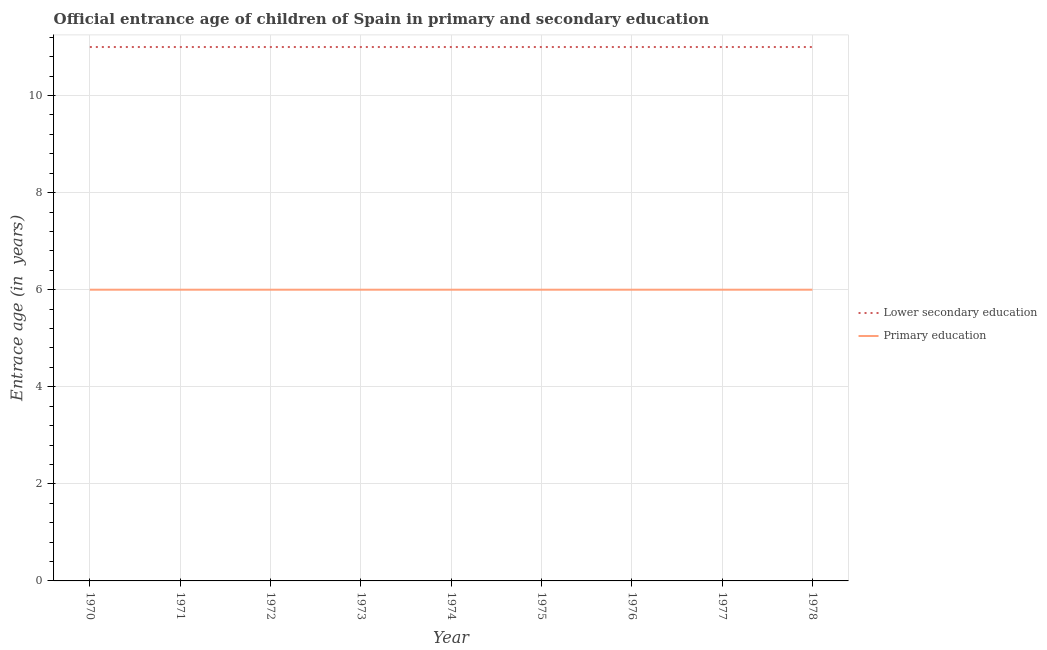How many different coloured lines are there?
Offer a terse response. 2. Does the line corresponding to entrance age of chiildren in primary education intersect with the line corresponding to entrance age of children in lower secondary education?
Offer a very short reply. No. What is the entrance age of chiildren in primary education in 1977?
Keep it short and to the point. 6. Across all years, what is the maximum entrance age of children in lower secondary education?
Your response must be concise. 11. Across all years, what is the minimum entrance age of children in lower secondary education?
Make the answer very short. 11. What is the total entrance age of children in lower secondary education in the graph?
Keep it short and to the point. 99. What is the difference between the entrance age of children in lower secondary education in 1978 and the entrance age of chiildren in primary education in 1973?
Keep it short and to the point. 5. What is the average entrance age of children in lower secondary education per year?
Give a very brief answer. 11. In the year 1978, what is the difference between the entrance age of chiildren in primary education and entrance age of children in lower secondary education?
Your response must be concise. -5. Is the entrance age of chiildren in primary education in 1977 less than that in 1978?
Ensure brevity in your answer.  No. In how many years, is the entrance age of chiildren in primary education greater than the average entrance age of chiildren in primary education taken over all years?
Offer a very short reply. 0. Does the entrance age of children in lower secondary education monotonically increase over the years?
Keep it short and to the point. No. What is the difference between two consecutive major ticks on the Y-axis?
Provide a short and direct response. 2. Does the graph contain any zero values?
Offer a terse response. No. Where does the legend appear in the graph?
Keep it short and to the point. Center right. What is the title of the graph?
Ensure brevity in your answer.  Official entrance age of children of Spain in primary and secondary education. Does "Malaria" appear as one of the legend labels in the graph?
Give a very brief answer. No. What is the label or title of the Y-axis?
Your answer should be very brief. Entrace age (in  years). What is the Entrace age (in  years) in Lower secondary education in 1970?
Offer a very short reply. 11. What is the Entrace age (in  years) of Lower secondary education in 1972?
Offer a very short reply. 11. What is the Entrace age (in  years) of Lower secondary education in 1973?
Give a very brief answer. 11. What is the Entrace age (in  years) in Primary education in 1973?
Offer a very short reply. 6. What is the Entrace age (in  years) in Lower secondary education in 1974?
Keep it short and to the point. 11. What is the Entrace age (in  years) of Lower secondary education in 1975?
Give a very brief answer. 11. What is the Entrace age (in  years) in Lower secondary education in 1977?
Offer a terse response. 11. Across all years, what is the maximum Entrace age (in  years) of Primary education?
Offer a terse response. 6. Across all years, what is the minimum Entrace age (in  years) in Lower secondary education?
Make the answer very short. 11. Across all years, what is the minimum Entrace age (in  years) of Primary education?
Keep it short and to the point. 6. What is the total Entrace age (in  years) in Lower secondary education in the graph?
Offer a terse response. 99. What is the difference between the Entrace age (in  years) in Lower secondary education in 1970 and that in 1971?
Give a very brief answer. 0. What is the difference between the Entrace age (in  years) in Lower secondary education in 1970 and that in 1972?
Make the answer very short. 0. What is the difference between the Entrace age (in  years) of Lower secondary education in 1970 and that in 1973?
Offer a very short reply. 0. What is the difference between the Entrace age (in  years) of Primary education in 1970 and that in 1973?
Offer a very short reply. 0. What is the difference between the Entrace age (in  years) of Lower secondary education in 1970 and that in 1974?
Keep it short and to the point. 0. What is the difference between the Entrace age (in  years) of Lower secondary education in 1970 and that in 1975?
Your answer should be very brief. 0. What is the difference between the Entrace age (in  years) in Primary education in 1970 and that in 1975?
Your response must be concise. 0. What is the difference between the Entrace age (in  years) of Lower secondary education in 1970 and that in 1976?
Make the answer very short. 0. What is the difference between the Entrace age (in  years) in Primary education in 1970 and that in 1976?
Your response must be concise. 0. What is the difference between the Entrace age (in  years) in Lower secondary education in 1970 and that in 1978?
Offer a terse response. 0. What is the difference between the Entrace age (in  years) in Lower secondary education in 1971 and that in 1973?
Offer a terse response. 0. What is the difference between the Entrace age (in  years) in Primary education in 1971 and that in 1974?
Make the answer very short. 0. What is the difference between the Entrace age (in  years) of Lower secondary education in 1971 and that in 1978?
Ensure brevity in your answer.  0. What is the difference between the Entrace age (in  years) of Primary education in 1971 and that in 1978?
Give a very brief answer. 0. What is the difference between the Entrace age (in  years) in Lower secondary education in 1972 and that in 1975?
Ensure brevity in your answer.  0. What is the difference between the Entrace age (in  years) of Primary education in 1972 and that in 1976?
Provide a short and direct response. 0. What is the difference between the Entrace age (in  years) of Lower secondary education in 1972 and that in 1977?
Provide a short and direct response. 0. What is the difference between the Entrace age (in  years) in Primary education in 1972 and that in 1977?
Make the answer very short. 0. What is the difference between the Entrace age (in  years) in Lower secondary education in 1972 and that in 1978?
Your answer should be very brief. 0. What is the difference between the Entrace age (in  years) of Primary education in 1972 and that in 1978?
Offer a terse response. 0. What is the difference between the Entrace age (in  years) of Lower secondary education in 1973 and that in 1974?
Your answer should be compact. 0. What is the difference between the Entrace age (in  years) in Primary education in 1973 and that in 1974?
Provide a succinct answer. 0. What is the difference between the Entrace age (in  years) in Primary education in 1973 and that in 1975?
Your answer should be very brief. 0. What is the difference between the Entrace age (in  years) in Lower secondary education in 1973 and that in 1978?
Your answer should be very brief. 0. What is the difference between the Entrace age (in  years) of Primary education in 1973 and that in 1978?
Ensure brevity in your answer.  0. What is the difference between the Entrace age (in  years) in Primary education in 1974 and that in 1976?
Provide a short and direct response. 0. What is the difference between the Entrace age (in  years) of Primary education in 1974 and that in 1977?
Provide a succinct answer. 0. What is the difference between the Entrace age (in  years) in Lower secondary education in 1974 and that in 1978?
Make the answer very short. 0. What is the difference between the Entrace age (in  years) of Primary education in 1974 and that in 1978?
Provide a short and direct response. 0. What is the difference between the Entrace age (in  years) in Lower secondary education in 1975 and that in 1976?
Ensure brevity in your answer.  0. What is the difference between the Entrace age (in  years) in Lower secondary education in 1975 and that in 1978?
Make the answer very short. 0. What is the difference between the Entrace age (in  years) in Primary education in 1976 and that in 1977?
Your answer should be compact. 0. What is the difference between the Entrace age (in  years) in Lower secondary education in 1976 and that in 1978?
Offer a terse response. 0. What is the difference between the Entrace age (in  years) in Primary education in 1977 and that in 1978?
Provide a short and direct response. 0. What is the difference between the Entrace age (in  years) of Lower secondary education in 1970 and the Entrace age (in  years) of Primary education in 1971?
Give a very brief answer. 5. What is the difference between the Entrace age (in  years) in Lower secondary education in 1970 and the Entrace age (in  years) in Primary education in 1973?
Give a very brief answer. 5. What is the difference between the Entrace age (in  years) of Lower secondary education in 1970 and the Entrace age (in  years) of Primary education in 1974?
Provide a succinct answer. 5. What is the difference between the Entrace age (in  years) of Lower secondary education in 1970 and the Entrace age (in  years) of Primary education in 1976?
Your answer should be compact. 5. What is the difference between the Entrace age (in  years) of Lower secondary education in 1970 and the Entrace age (in  years) of Primary education in 1977?
Give a very brief answer. 5. What is the difference between the Entrace age (in  years) in Lower secondary education in 1970 and the Entrace age (in  years) in Primary education in 1978?
Offer a terse response. 5. What is the difference between the Entrace age (in  years) in Lower secondary education in 1971 and the Entrace age (in  years) in Primary education in 1972?
Ensure brevity in your answer.  5. What is the difference between the Entrace age (in  years) in Lower secondary education in 1971 and the Entrace age (in  years) in Primary education in 1974?
Provide a succinct answer. 5. What is the difference between the Entrace age (in  years) of Lower secondary education in 1971 and the Entrace age (in  years) of Primary education in 1976?
Your answer should be very brief. 5. What is the difference between the Entrace age (in  years) in Lower secondary education in 1971 and the Entrace age (in  years) in Primary education in 1978?
Your answer should be very brief. 5. What is the difference between the Entrace age (in  years) in Lower secondary education in 1972 and the Entrace age (in  years) in Primary education in 1974?
Make the answer very short. 5. What is the difference between the Entrace age (in  years) of Lower secondary education in 1972 and the Entrace age (in  years) of Primary education in 1975?
Provide a short and direct response. 5. What is the difference between the Entrace age (in  years) of Lower secondary education in 1972 and the Entrace age (in  years) of Primary education in 1976?
Keep it short and to the point. 5. What is the difference between the Entrace age (in  years) in Lower secondary education in 1972 and the Entrace age (in  years) in Primary education in 1977?
Offer a very short reply. 5. What is the difference between the Entrace age (in  years) of Lower secondary education in 1972 and the Entrace age (in  years) of Primary education in 1978?
Keep it short and to the point. 5. What is the difference between the Entrace age (in  years) in Lower secondary education in 1973 and the Entrace age (in  years) in Primary education in 1975?
Keep it short and to the point. 5. What is the difference between the Entrace age (in  years) in Lower secondary education in 1973 and the Entrace age (in  years) in Primary education in 1976?
Make the answer very short. 5. What is the difference between the Entrace age (in  years) of Lower secondary education in 1973 and the Entrace age (in  years) of Primary education in 1977?
Ensure brevity in your answer.  5. What is the difference between the Entrace age (in  years) in Lower secondary education in 1973 and the Entrace age (in  years) in Primary education in 1978?
Give a very brief answer. 5. What is the difference between the Entrace age (in  years) of Lower secondary education in 1976 and the Entrace age (in  years) of Primary education in 1977?
Provide a succinct answer. 5. What is the difference between the Entrace age (in  years) of Lower secondary education in 1976 and the Entrace age (in  years) of Primary education in 1978?
Keep it short and to the point. 5. What is the difference between the Entrace age (in  years) of Lower secondary education in 1977 and the Entrace age (in  years) of Primary education in 1978?
Your answer should be very brief. 5. What is the average Entrace age (in  years) of Lower secondary education per year?
Keep it short and to the point. 11. In the year 1970, what is the difference between the Entrace age (in  years) in Lower secondary education and Entrace age (in  years) in Primary education?
Your answer should be very brief. 5. In the year 1972, what is the difference between the Entrace age (in  years) in Lower secondary education and Entrace age (in  years) in Primary education?
Your answer should be very brief. 5. In the year 1975, what is the difference between the Entrace age (in  years) of Lower secondary education and Entrace age (in  years) of Primary education?
Your response must be concise. 5. In the year 1976, what is the difference between the Entrace age (in  years) of Lower secondary education and Entrace age (in  years) of Primary education?
Your response must be concise. 5. In the year 1977, what is the difference between the Entrace age (in  years) of Lower secondary education and Entrace age (in  years) of Primary education?
Your response must be concise. 5. In the year 1978, what is the difference between the Entrace age (in  years) in Lower secondary education and Entrace age (in  years) in Primary education?
Offer a terse response. 5. What is the ratio of the Entrace age (in  years) in Lower secondary education in 1970 to that in 1972?
Make the answer very short. 1. What is the ratio of the Entrace age (in  years) in Primary education in 1970 to that in 1972?
Your answer should be very brief. 1. What is the ratio of the Entrace age (in  years) of Primary education in 1970 to that in 1973?
Offer a very short reply. 1. What is the ratio of the Entrace age (in  years) of Lower secondary education in 1970 to that in 1974?
Offer a terse response. 1. What is the ratio of the Entrace age (in  years) in Primary education in 1970 to that in 1974?
Provide a short and direct response. 1. What is the ratio of the Entrace age (in  years) in Lower secondary education in 1970 to that in 1975?
Provide a succinct answer. 1. What is the ratio of the Entrace age (in  years) of Lower secondary education in 1970 to that in 1976?
Your response must be concise. 1. What is the ratio of the Entrace age (in  years) of Primary education in 1970 to that in 1976?
Offer a terse response. 1. What is the ratio of the Entrace age (in  years) of Lower secondary education in 1970 to that in 1977?
Give a very brief answer. 1. What is the ratio of the Entrace age (in  years) of Primary education in 1970 to that in 1977?
Your answer should be compact. 1. What is the ratio of the Entrace age (in  years) in Primary education in 1970 to that in 1978?
Offer a terse response. 1. What is the ratio of the Entrace age (in  years) of Lower secondary education in 1971 to that in 1972?
Ensure brevity in your answer.  1. What is the ratio of the Entrace age (in  years) of Primary education in 1971 to that in 1972?
Your answer should be compact. 1. What is the ratio of the Entrace age (in  years) of Primary education in 1971 to that in 1973?
Your answer should be very brief. 1. What is the ratio of the Entrace age (in  years) in Primary education in 1971 to that in 1974?
Your answer should be very brief. 1. What is the ratio of the Entrace age (in  years) of Lower secondary education in 1971 to that in 1975?
Make the answer very short. 1. What is the ratio of the Entrace age (in  years) of Lower secondary education in 1971 to that in 1978?
Provide a short and direct response. 1. What is the ratio of the Entrace age (in  years) of Primary education in 1971 to that in 1978?
Make the answer very short. 1. What is the ratio of the Entrace age (in  years) of Primary education in 1972 to that in 1973?
Your answer should be compact. 1. What is the ratio of the Entrace age (in  years) of Lower secondary education in 1972 to that in 1974?
Provide a succinct answer. 1. What is the ratio of the Entrace age (in  years) of Lower secondary education in 1972 to that in 1975?
Provide a succinct answer. 1. What is the ratio of the Entrace age (in  years) of Lower secondary education in 1972 to that in 1976?
Give a very brief answer. 1. What is the ratio of the Entrace age (in  years) in Primary education in 1972 to that in 1976?
Offer a very short reply. 1. What is the ratio of the Entrace age (in  years) of Lower secondary education in 1972 to that in 1978?
Your answer should be compact. 1. What is the ratio of the Entrace age (in  years) of Primary education in 1972 to that in 1978?
Offer a very short reply. 1. What is the ratio of the Entrace age (in  years) in Primary education in 1973 to that in 1974?
Provide a succinct answer. 1. What is the ratio of the Entrace age (in  years) in Lower secondary education in 1973 to that in 1975?
Keep it short and to the point. 1. What is the ratio of the Entrace age (in  years) in Primary education in 1973 to that in 1975?
Provide a succinct answer. 1. What is the ratio of the Entrace age (in  years) in Lower secondary education in 1973 to that in 1976?
Offer a very short reply. 1. What is the ratio of the Entrace age (in  years) of Primary education in 1973 to that in 1976?
Offer a terse response. 1. What is the ratio of the Entrace age (in  years) in Primary education in 1973 to that in 1977?
Offer a very short reply. 1. What is the ratio of the Entrace age (in  years) of Lower secondary education in 1974 to that in 1975?
Give a very brief answer. 1. What is the ratio of the Entrace age (in  years) in Primary education in 1974 to that in 1976?
Offer a very short reply. 1. What is the ratio of the Entrace age (in  years) in Lower secondary education in 1974 to that in 1977?
Offer a terse response. 1. What is the ratio of the Entrace age (in  years) in Primary education in 1974 to that in 1978?
Provide a short and direct response. 1. What is the ratio of the Entrace age (in  years) of Lower secondary education in 1975 to that in 1976?
Make the answer very short. 1. What is the ratio of the Entrace age (in  years) of Lower secondary education in 1975 to that in 1977?
Ensure brevity in your answer.  1. What is the ratio of the Entrace age (in  years) in Primary education in 1975 to that in 1977?
Offer a very short reply. 1. What is the ratio of the Entrace age (in  years) in Lower secondary education in 1975 to that in 1978?
Your answer should be compact. 1. What is the ratio of the Entrace age (in  years) of Primary education in 1975 to that in 1978?
Your response must be concise. 1. What is the ratio of the Entrace age (in  years) of Primary education in 1976 to that in 1978?
Offer a very short reply. 1. What is the ratio of the Entrace age (in  years) of Lower secondary education in 1977 to that in 1978?
Give a very brief answer. 1. What is the ratio of the Entrace age (in  years) in Primary education in 1977 to that in 1978?
Offer a very short reply. 1. What is the difference between the highest and the lowest Entrace age (in  years) of Lower secondary education?
Your answer should be very brief. 0. 